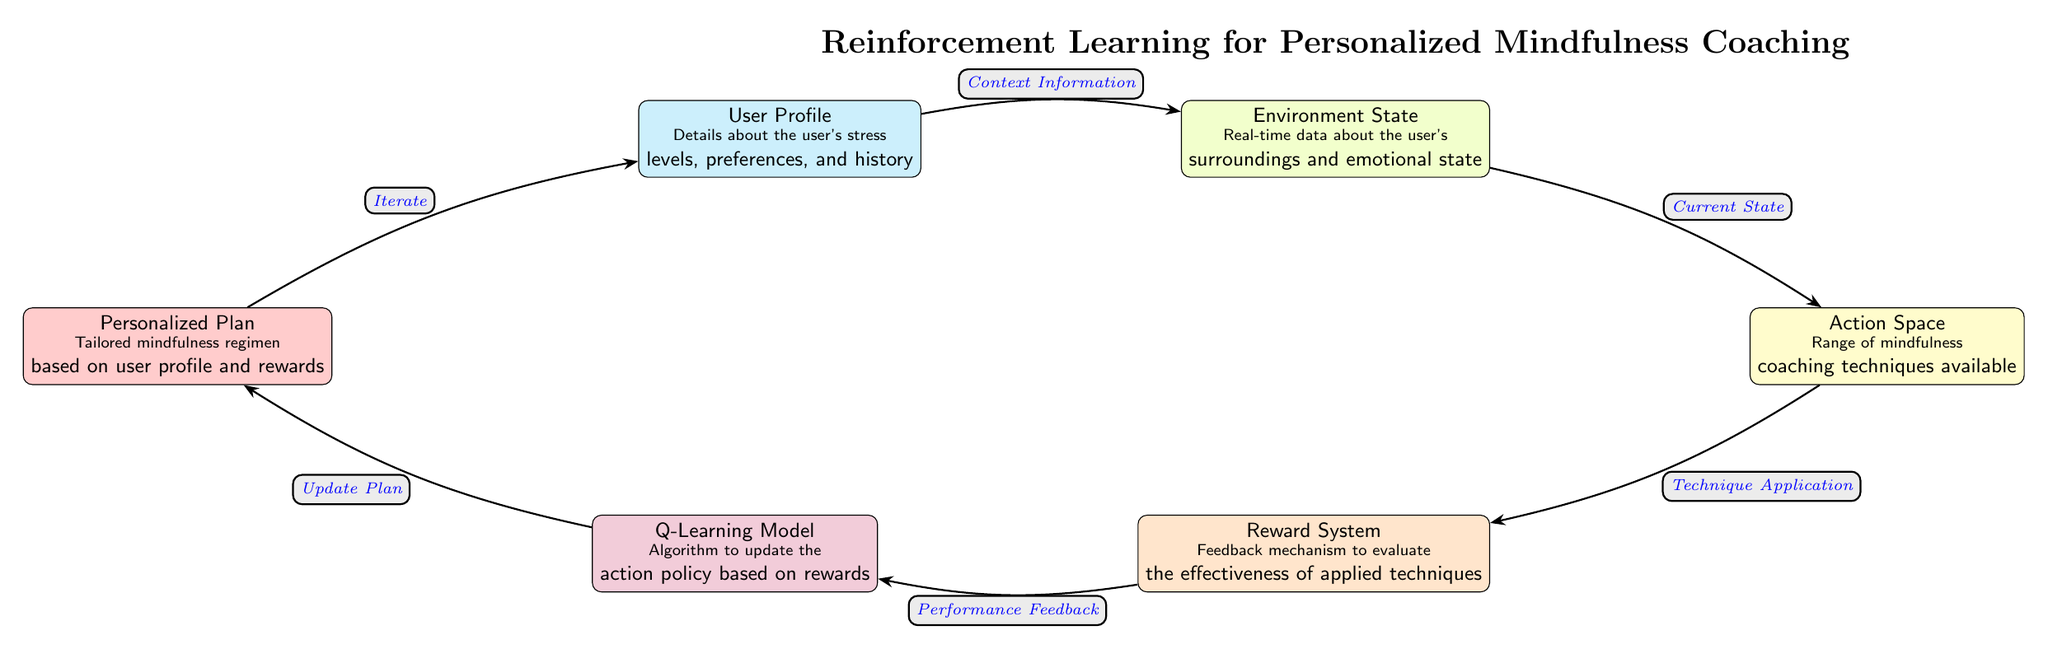What is the main algorithm used in this model? The main algorithm mentioned in the diagram is the Q-Learning Model, which is indicated in a purple node labeled "Q-Learning Model."
Answer: Q-Learning Model How many nodes are present in the diagram? By counting each distinct node shown in the diagram, there are a total of six nodes: User Profile, Environment State, Action Space, Reward System, Q-Learning Model, and Personalized Plan.
Answer: Six What type of information does the User Profile provide? The User Profile node contains details about the user's stress levels, preferences, and history, as specified in the diagram.
Answer: Stress levels, preferences, and history What does the Action Space node refer to? The Action Space node refers to the range of mindfulness coaching techniques available, shown in the yellow node.
Answer: Mindfulness coaching techniques Which node receives performance feedback? The Reward System, represented in the orange node, receives performance feedback as indicated by the arrow connecting Reward System and Q-Learning Model.
Answer: Reward System How does the Personalized Plan relate to the Q-Learning Model? The Personalized Plan receives updates from the Q-Learning Model based on the rewards, indicating that the plan is tailored according to the effectiveness of the applied techniques.
Answer: Update Plan What is indicated by the flow direction from the Action Space to the Reward System? The flow direction indicates that after applying the techniques from the Action Space, the performance is evaluated through the Reward System, signifying that this is a feedback loop.
Answer: Technique Application What is the final output of this reinforcement learning approach? The final output is the Personalized Plan that is customized based on the iterative process of user feedback and the reinforcement learning model updates.
Answer: Personalized Plan 